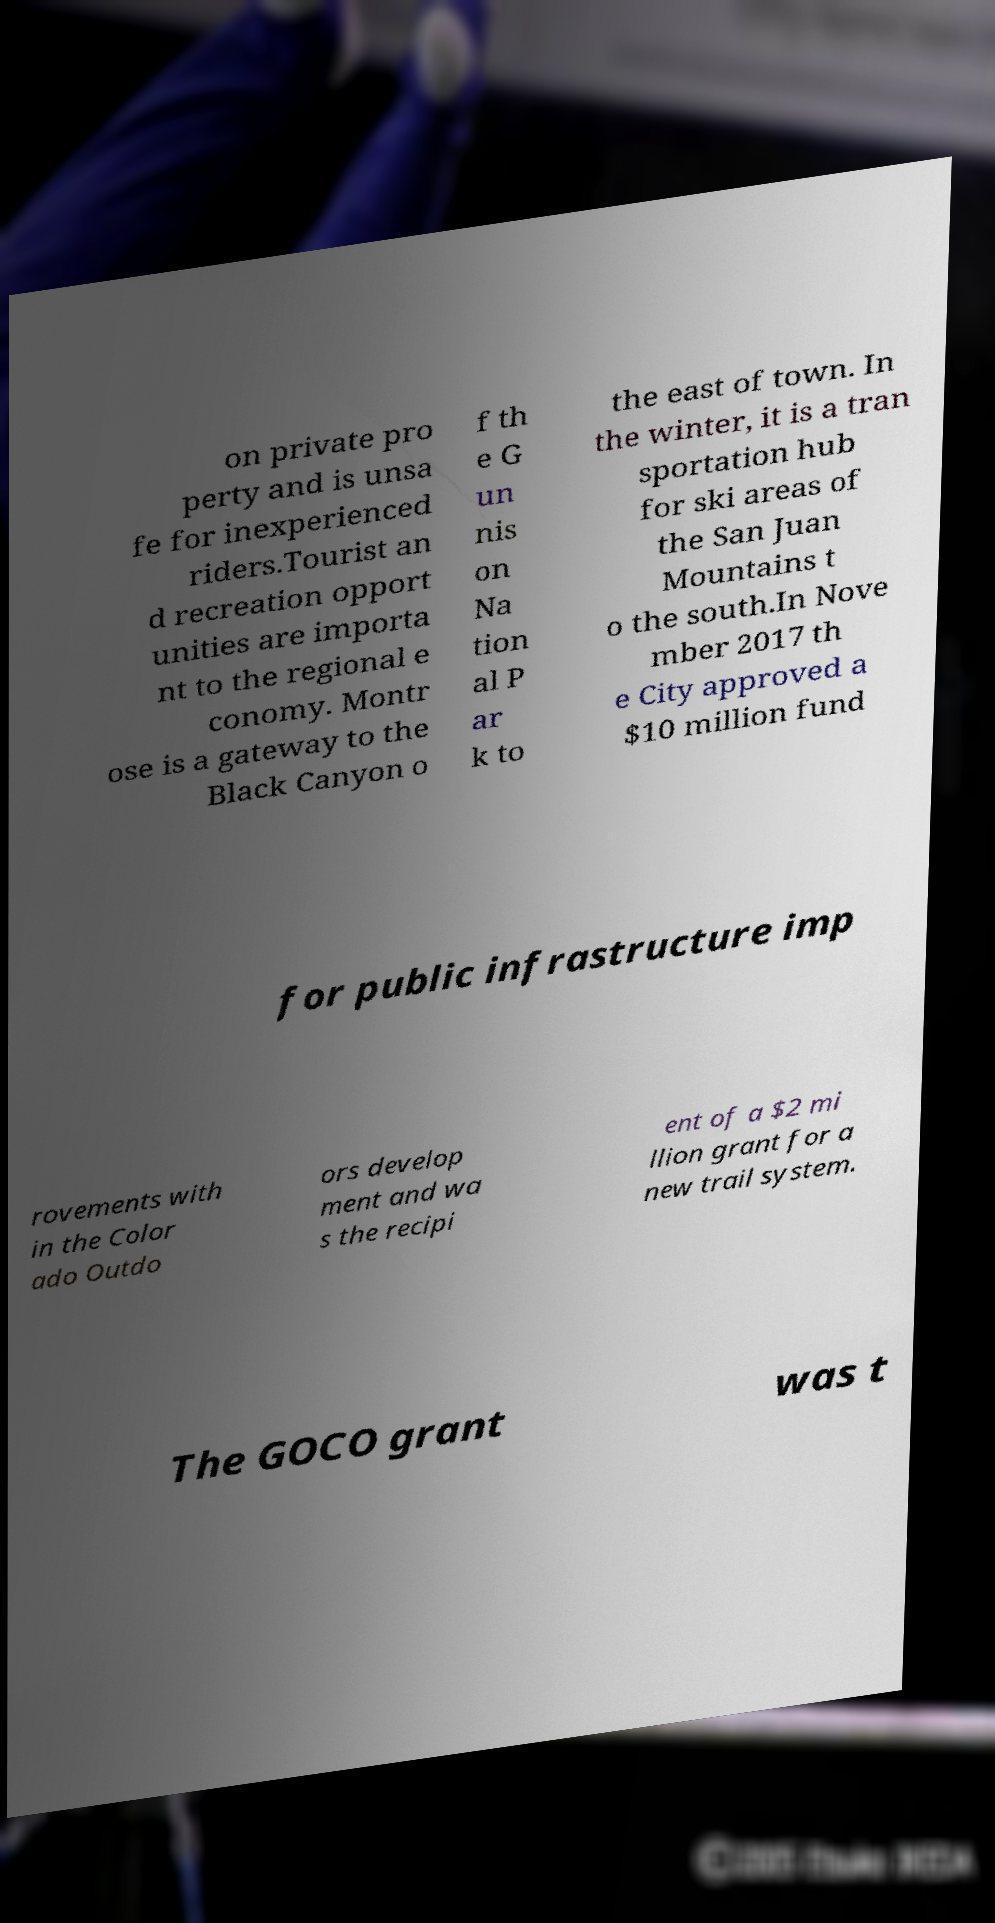What messages or text are displayed in this image? I need them in a readable, typed format. on private pro perty and is unsa fe for inexperienced riders.Tourist an d recreation opport unities are importa nt to the regional e conomy. Montr ose is a gateway to the Black Canyon o f th e G un nis on Na tion al P ar k to the east of town. In the winter, it is a tran sportation hub for ski areas of the San Juan Mountains t o the south.In Nove mber 2017 th e City approved a $10 million fund for public infrastructure imp rovements with in the Color ado Outdo ors develop ment and wa s the recipi ent of a $2 mi llion grant for a new trail system. The GOCO grant was t 